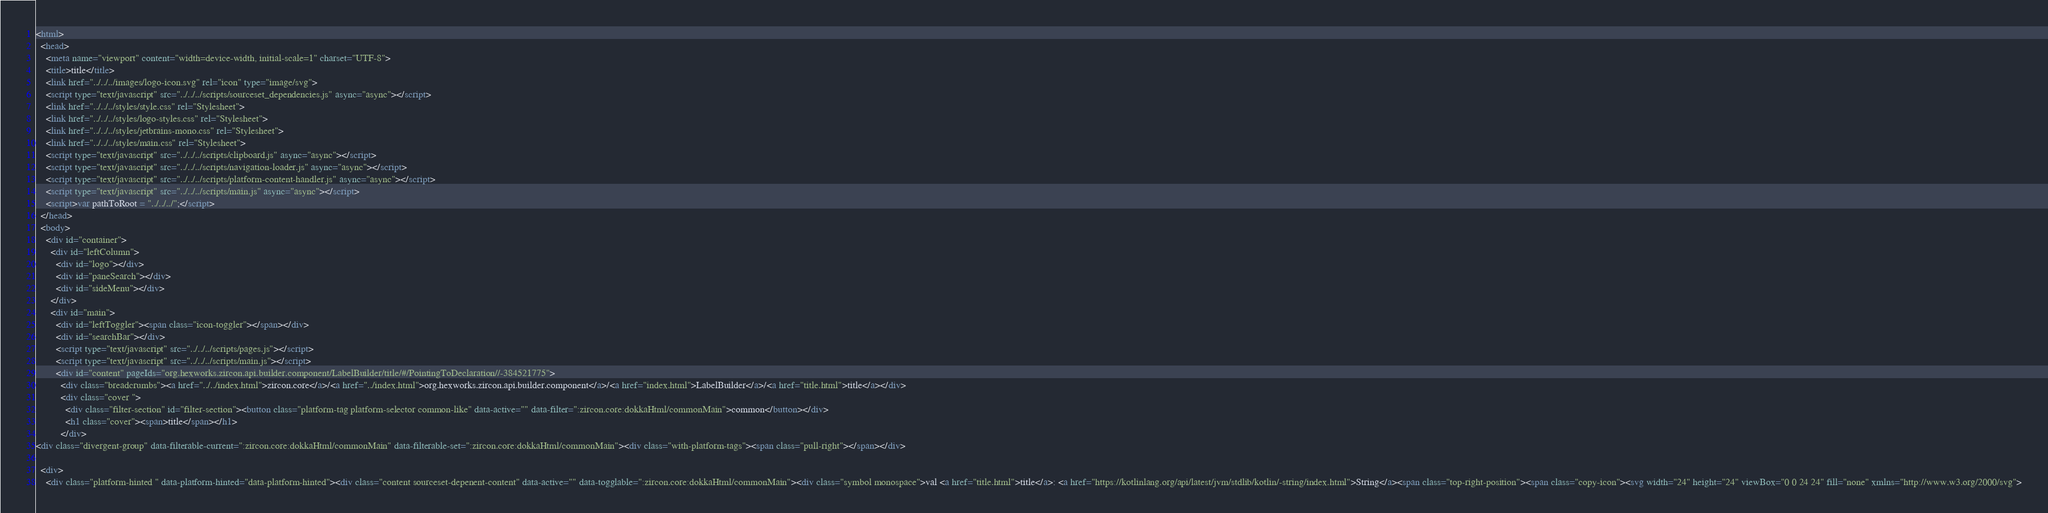Convert code to text. <code><loc_0><loc_0><loc_500><loc_500><_HTML_><html>
  <head>
    <meta name="viewport" content="width=device-width, initial-scale=1" charset="UTF-8">
    <title>title</title>
    <link href="../../../images/logo-icon.svg" rel="icon" type="image/svg">
    <script type="text/javascript" src="../../../scripts/sourceset_dependencies.js" async="async"></script>
    <link href="../../../styles/style.css" rel="Stylesheet">
    <link href="../../../styles/logo-styles.css" rel="Stylesheet">
    <link href="../../../styles/jetbrains-mono.css" rel="Stylesheet">
    <link href="../../../styles/main.css" rel="Stylesheet">
    <script type="text/javascript" src="../../../scripts/clipboard.js" async="async"></script>
    <script type="text/javascript" src="../../../scripts/navigation-loader.js" async="async"></script>
    <script type="text/javascript" src="../../../scripts/platform-content-handler.js" async="async"></script>
    <script type="text/javascript" src="../../../scripts/main.js" async="async"></script>
    <script>var pathToRoot = "../../../";</script>
  </head>
  <body>
    <div id="container">
      <div id="leftColumn">
        <div id="logo"></div>
        <div id="paneSearch"></div>
        <div id="sideMenu"></div>
      </div>
      <div id="main">
        <div id="leftToggler"><span class="icon-toggler"></span></div>
        <div id="searchBar"></div>
        <script type="text/javascript" src="../../../scripts/pages.js"></script>
        <script type="text/javascript" src="../../../scripts/main.js"></script>
        <div id="content" pageIds="org.hexworks.zircon.api.builder.component/LabelBuilder/title/#/PointingToDeclaration//-384521775">
          <div class="breadcrumbs"><a href="../../index.html">zircon.core</a>/<a href="../index.html">org.hexworks.zircon.api.builder.component</a>/<a href="index.html">LabelBuilder</a>/<a href="title.html">title</a></div>
          <div class="cover ">
            <div class="filter-section" id="filter-section"><button class="platform-tag platform-selector common-like" data-active="" data-filter=":zircon.core:dokkaHtml/commonMain">common</button></div>
            <h1 class="cover"><span>title</span></h1>
          </div>
<div class="divergent-group" data-filterable-current=":zircon.core:dokkaHtml/commonMain" data-filterable-set=":zircon.core:dokkaHtml/commonMain"><div class="with-platform-tags"><span class="pull-right"></span></div>

  <div>
    <div class="platform-hinted " data-platform-hinted="data-platform-hinted"><div class="content sourceset-depenent-content" data-active="" data-togglable=":zircon.core:dokkaHtml/commonMain"><div class="symbol monospace">val <a href="title.html">title</a>: <a href="https://kotlinlang.org/api/latest/jvm/stdlib/kotlin/-string/index.html">String</a><span class="top-right-position"><span class="copy-icon"><svg width="24" height="24" viewBox="0 0 24 24" fill="none" xmlns="http://www.w3.org/2000/svg"></code> 